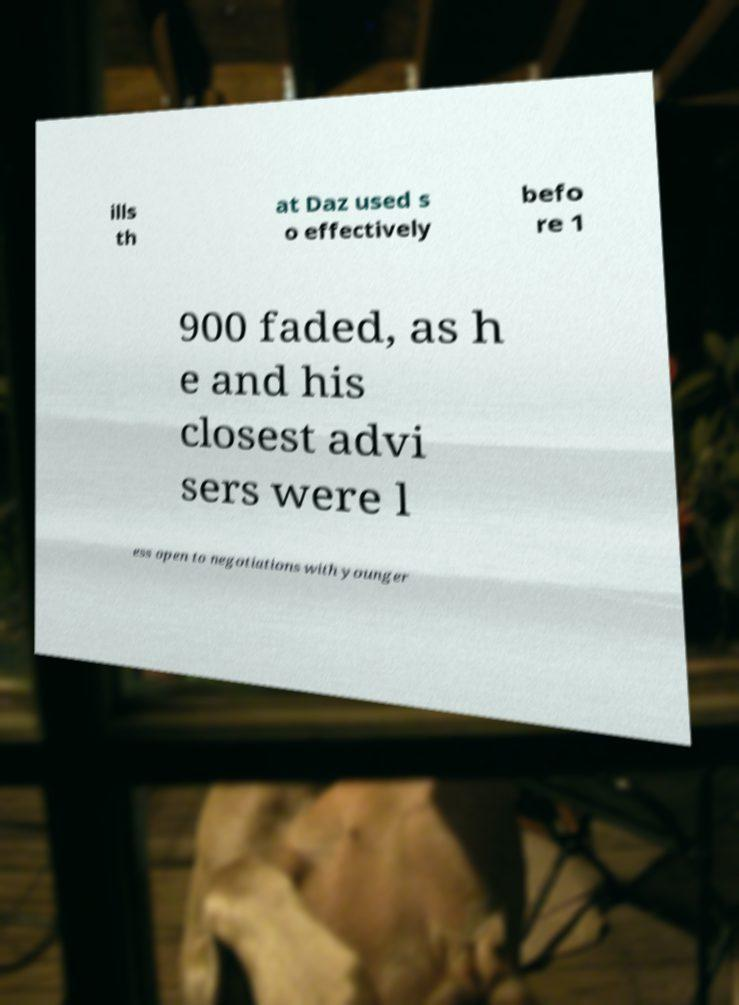There's text embedded in this image that I need extracted. Can you transcribe it verbatim? ills th at Daz used s o effectively befo re 1 900 faded, as h e and his closest advi sers were l ess open to negotiations with younger 